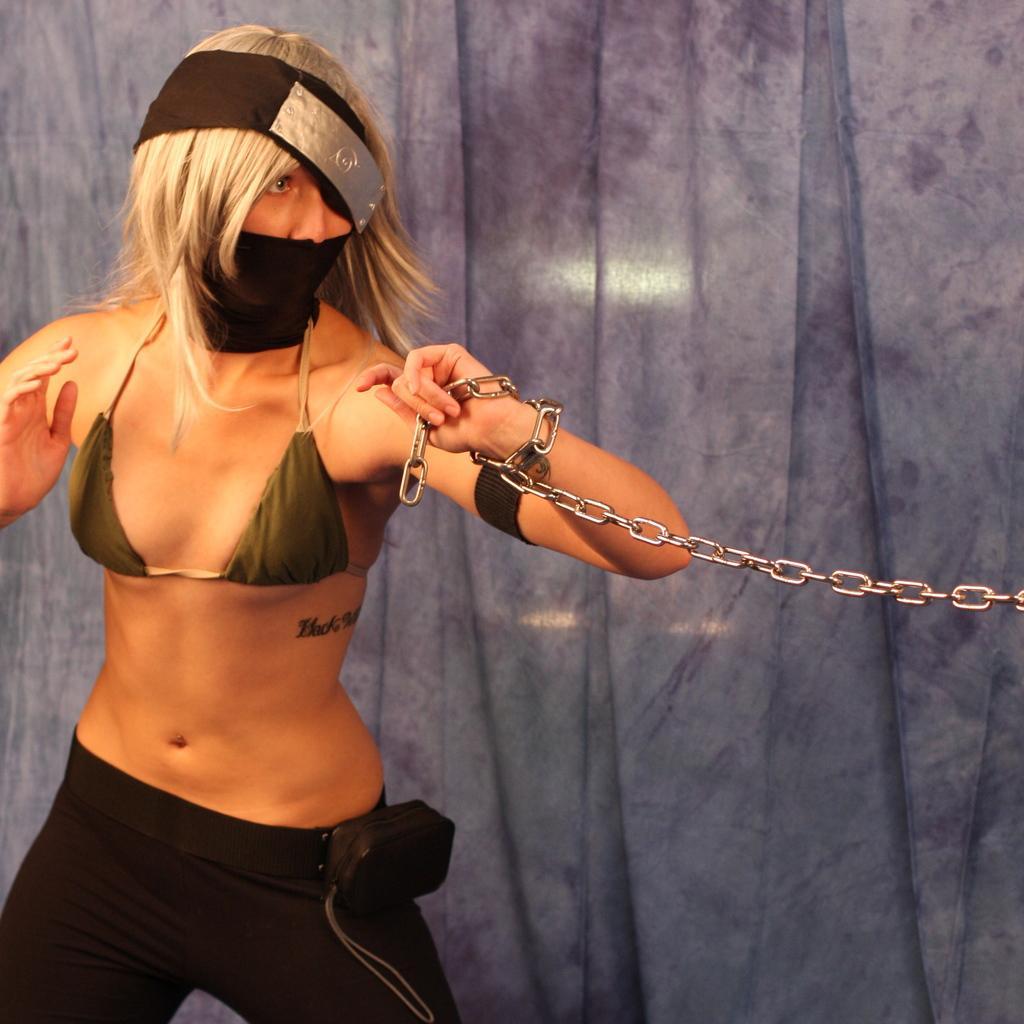Can you describe this image briefly? In this image we can see a person/woman standing and wearing a mask. And we can see the metal chain. 